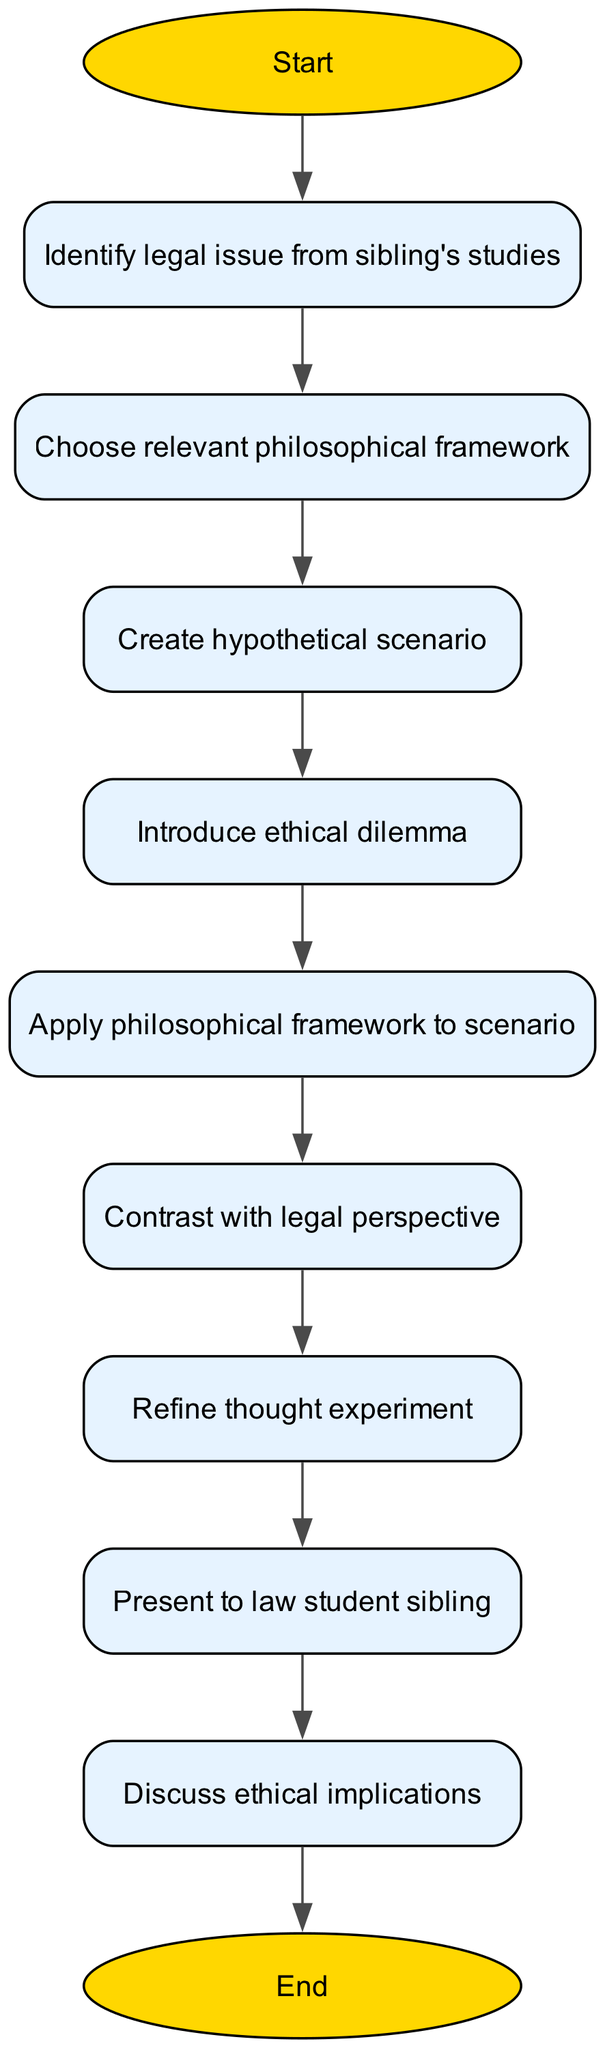What is the first step in the flowchart? The first step is represented by the "Start" node, which initiates the thought experiment process.
Answer: Start How many nodes are present in the flowchart? The diagram features 11 distinct nodes that represent various steps in constructing the philosophical thought experiment.
Answer: 11 Which node follows the "Identify legal issue from sibling's studies"? The node that directly follows this one is "Choose relevant philosophical framework," indicating the next step after identifying the legal issue.
Answer: Choose relevant philosophical framework What is the last step before ending the flowchart? The final step before reaching the "End" node is "Discuss ethical implications," which suggests that the implications of the thought experiment are evaluated.
Answer: Discuss ethical implications Which two nodes are connected by an edge that indicates a refinement process? The "Contrast with legal perspective" and "Refine thought experiment" nodes are connected, showing that after contrasting, one refines the thought experiment.
Answer: Contrast with legal perspective and Refine thought experiment How many connections are there in total between the nodes? There are 9 connections depicted in the flowchart that link the steps of the process, illustrating the flow of logic between each stage.
Answer: 9 Which node introduces a critical aspect of the thought experiment? The node that introduces a critical aspect is "Introduce ethical dilemma," which is crucial for challenging legal perspectives using philosophical reasoning.
Answer: Introduce ethical dilemma What step must be completed before presenting to the law student sibling? Before presenting to the sibling, the step "Refine thought experiment" must be completed, indicating preparation for the discussion.
Answer: Refine thought experiment What is the purpose of the "Apply philosophical framework to scenario" node? This node is significant as it emphasizes the application of philosophical principles to the hypothetical scenario created earlier, forming the basis for the thought experiment.
Answer: Apply philosophical framework to scenario 